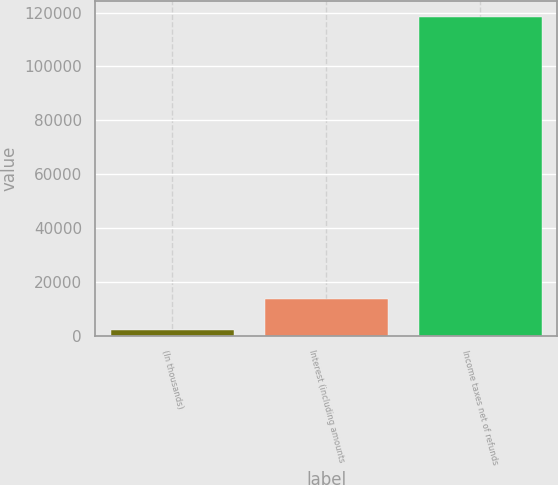<chart> <loc_0><loc_0><loc_500><loc_500><bar_chart><fcel>(In thousands)<fcel>Interest (including amounts<fcel>Income taxes net of refunds<nl><fcel>2015<fcel>13654.4<fcel>118409<nl></chart> 